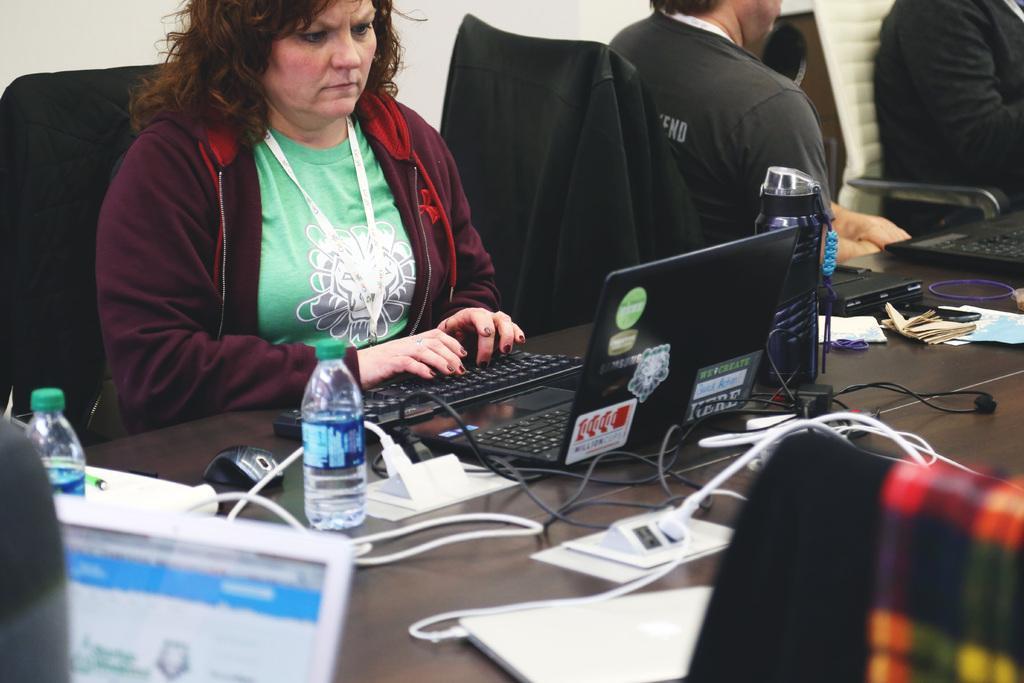Could you give a brief overview of what you see in this image? There is a woman sitting in chair and operating a laptop in front of her which is placed on the table and there are few other objects beside it and there are two other persons sitting beside her. 